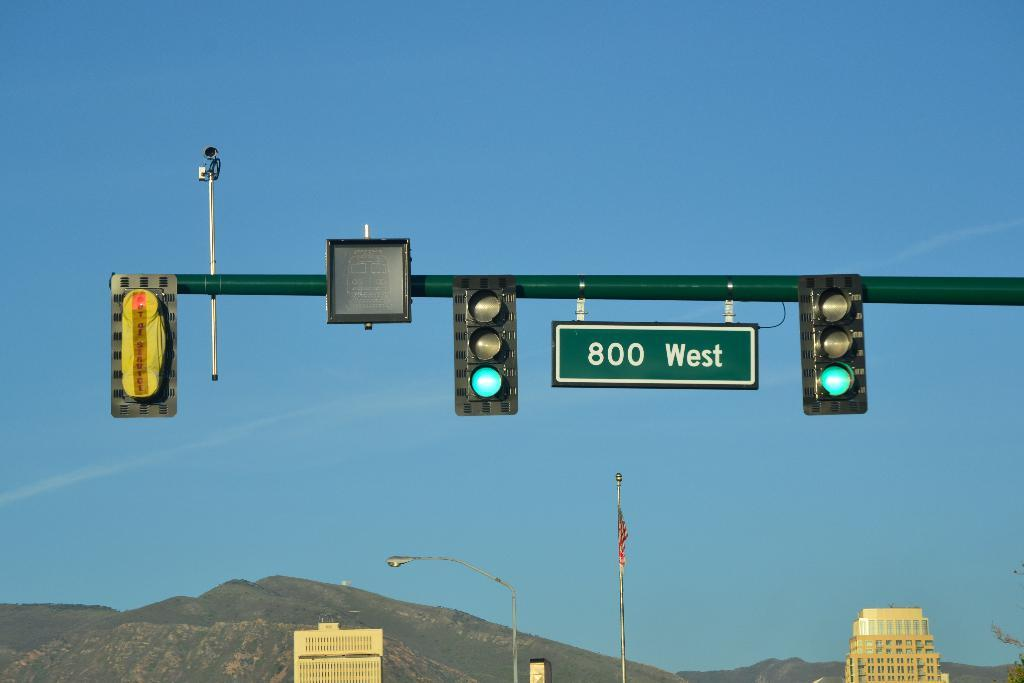<image>
Create a compact narrative representing the image presented. Two traffic lights both on green and between a sign has 800 West on it. 